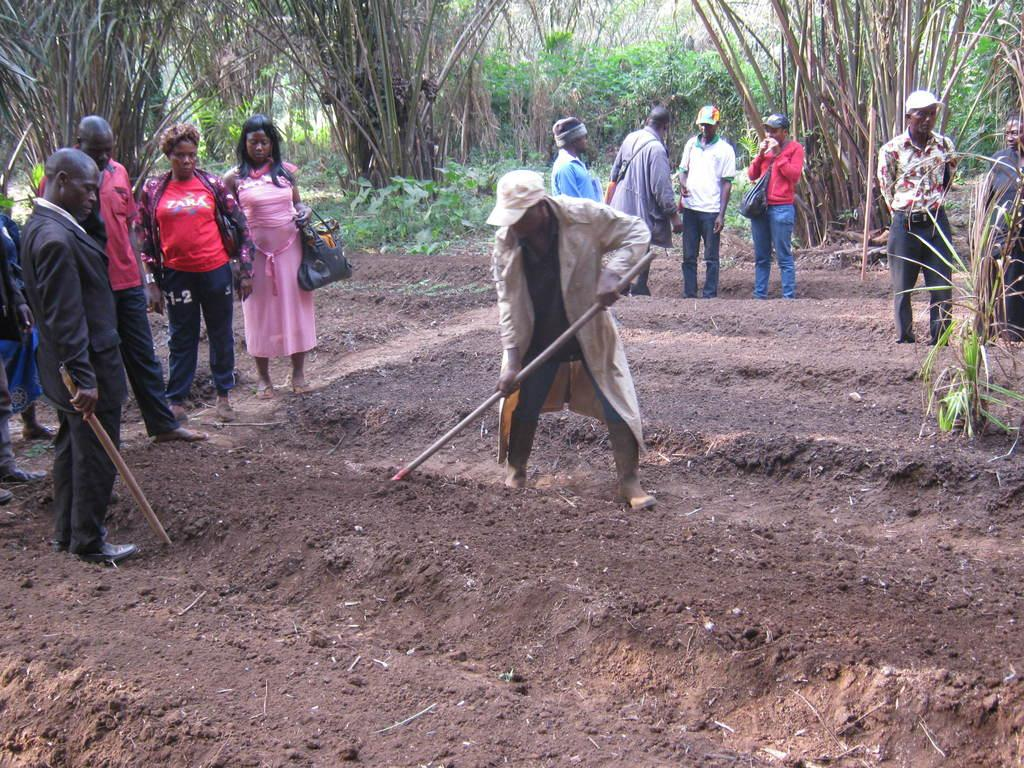What are the people in the image doing? There are groups of people standing in the image. What is the man with the stick doing? The man is holding a stick and digging. What type of vegetation can be seen in the image? There are trees and plants in the image. What type of apple is being cooked by the man in the image? There is no man cooking an apple in the image; the man is holding a stick and digging. How many turkeys can be seen in the image? There are no turkeys present in the image. 